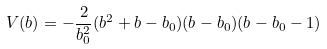<formula> <loc_0><loc_0><loc_500><loc_500>V ( b ) = - \frac { 2 } { b _ { 0 } ^ { 2 } } ( b ^ { 2 } + b - b _ { 0 } ) ( b - b _ { 0 } ) ( b - b _ { 0 } - 1 )</formula> 